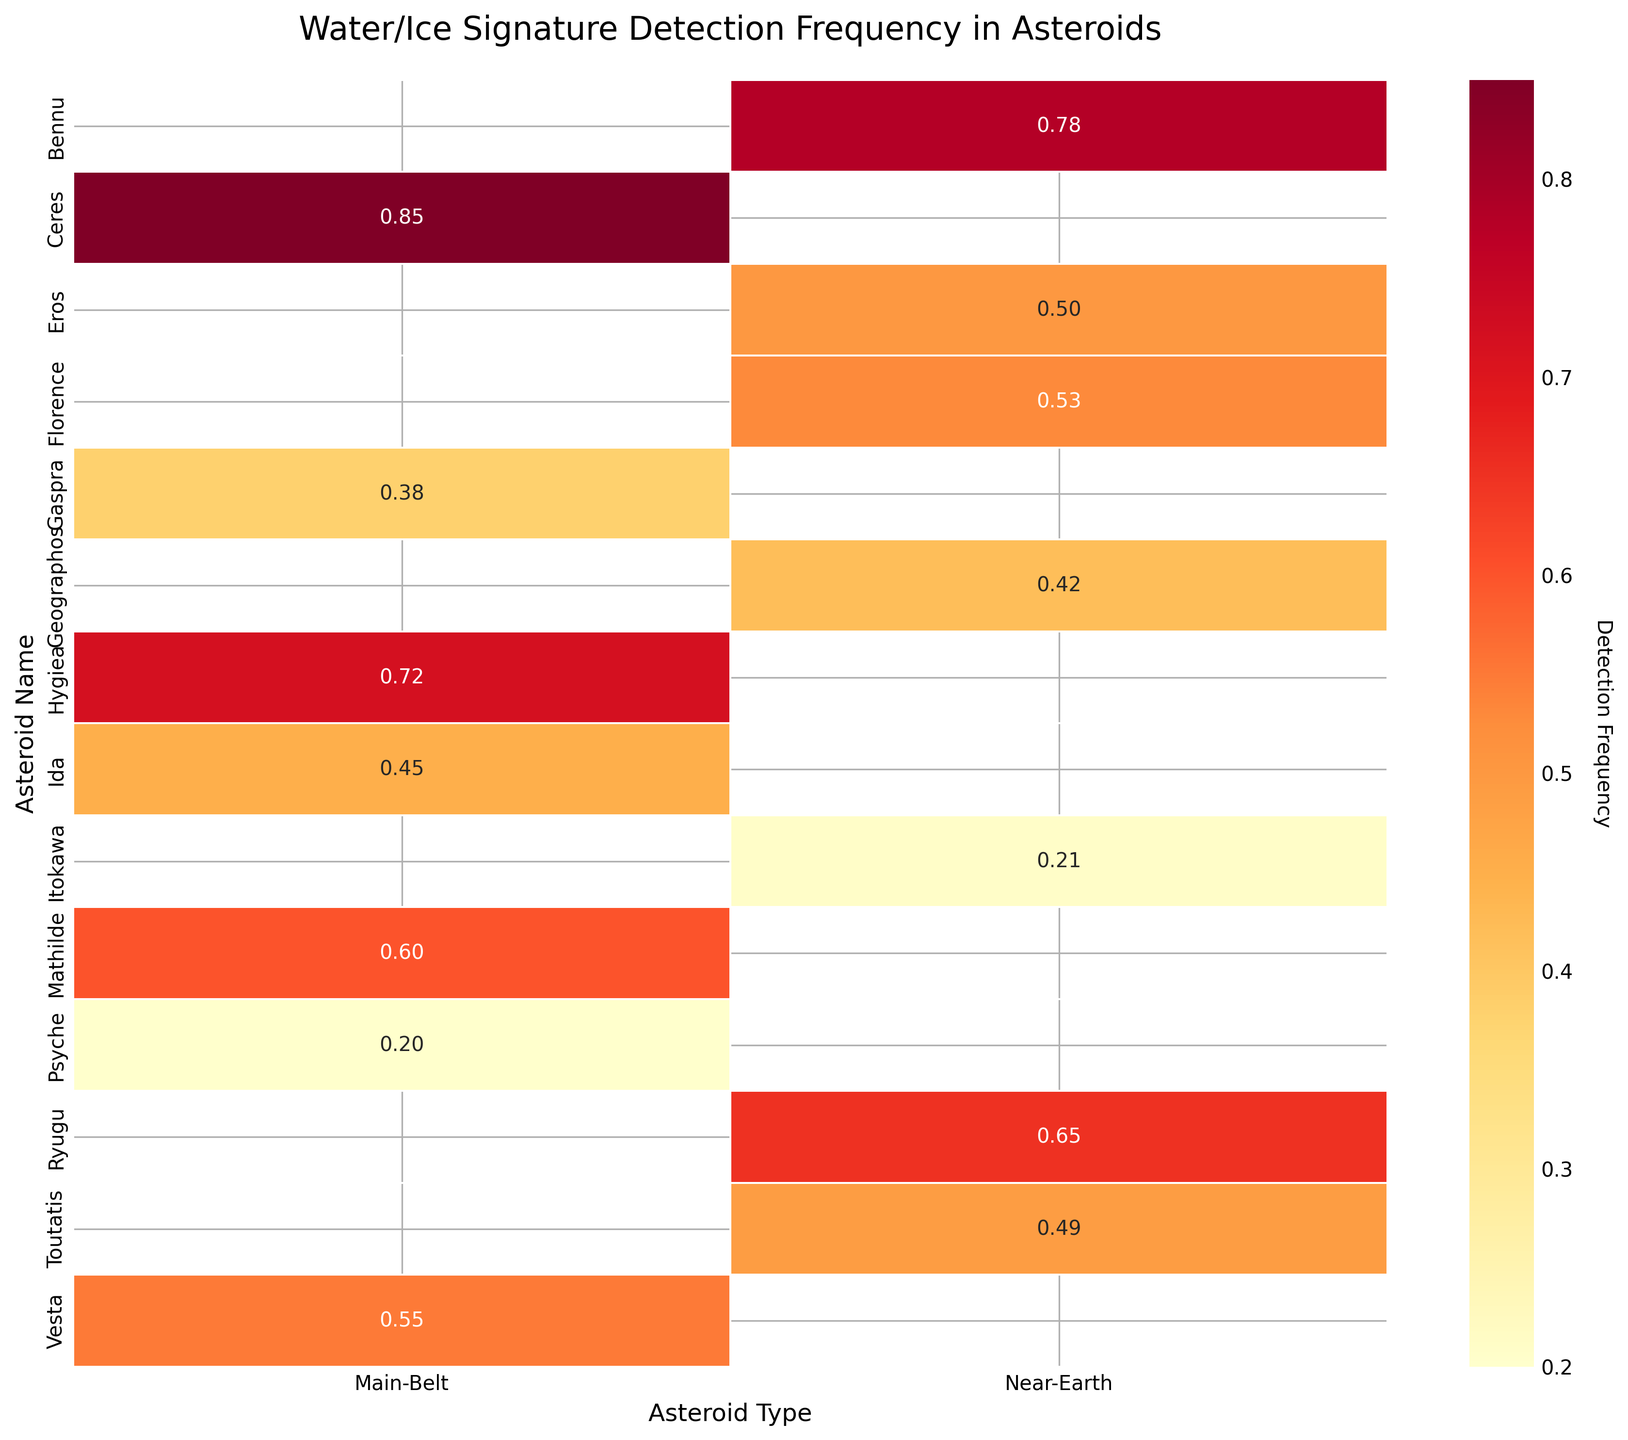What is the title of the figure? The title is the text displayed prominently at the top of the figure. In this heatmap, it reads "Water/Ice Signature Detection Frequency in Asteroids".
Answer: Water/Ice Signature Detection Frequency in Asteroids What is the detection frequency of water/ice signatures for the asteroid Ryugu? To find the detection frequency for Ryugu, look at the value in the row labeled "Ryugu". The value is 0.65.
Answer: 0.65 Which asteroid has the highest detection frequency and what is that value? The highest value in the heatmap represents the highest detection frequency. Look for the largest number in the heatmap, which is 0.85 for the asteroid "Ceres".
Answer: Ceres, 0.85 How many Main-Belt asteroids have a detection frequency above 0.5? Scan the Main-Belt column and count the number of asteroids with a frequency above 0.5. Mathilde (0.60), Hygiea (0.72), Ceres (0.85), and Vesta (0.55) fit this criterion.
Answer: 4 What is the average detection frequency for Near-Earth asteroids? Add up the detection frequencies for all Near-Earth asteroids and divide by their number. The frequencies are 0.65, 0.78, 0.53, 0.50, 0.42, 0.21, 0.49. The sum is 3.58, and there are 7 asteroids. So, 3.58 / 7.
Answer: 0.51 Which Near-Earth asteroid has the lowest detection frequency and what is that value? Look for the smallest value in the Near-Earth column. The lowest detection frequency is 0.21 for the asteroid "Itokawa".
Answer: Itokawa, 0.21 What is the difference in detection frequency between the asteroids Bennu and Eros? Find the detection frequencies for Bennu (0.78) and Eros (0.50). Subtract the smaller value from the larger one. So, 0.78 - 0.50.
Answer: 0.28 Which asteroid types have more asteroids with a detection frequency above 0.5? Count the number of asteroids in each type with a detection frequency above 0.5. For Near-Earth, the values above 0.5 are 0.65, 0.78, 0.53. For Main-Belt, the values above 0.5 are 0.60, 0.72, 0.85, 0.55. Near-Earth has 3, and Main-Belt has 4. Main-Belt has more.
Answer: Main-Belt Which Main-Belt asteroid has the lowest detection frequency and what is that value? Check the Main-Belt column for the lowest value, which is 0.20 for the asteroid "Psyche".
Answer: Psyche, 0.20 